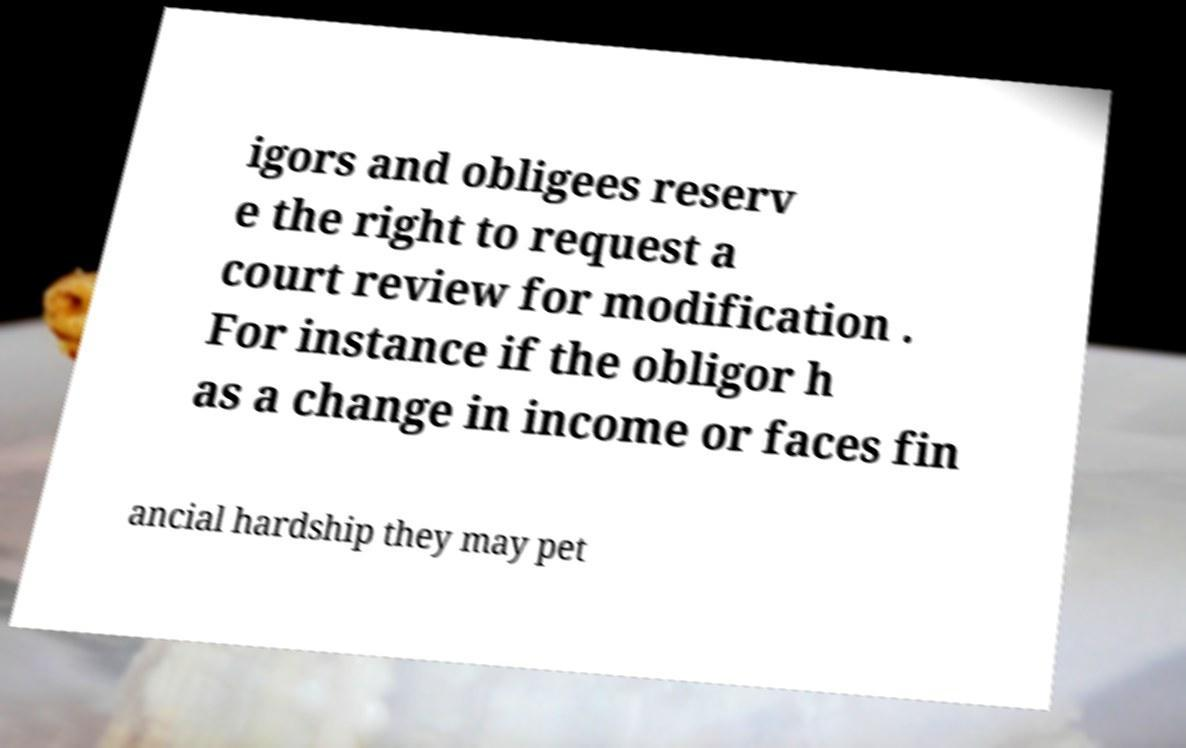For documentation purposes, I need the text within this image transcribed. Could you provide that? igors and obligees reserv e the right to request a court review for modification . For instance if the obligor h as a change in income or faces fin ancial hardship they may pet 